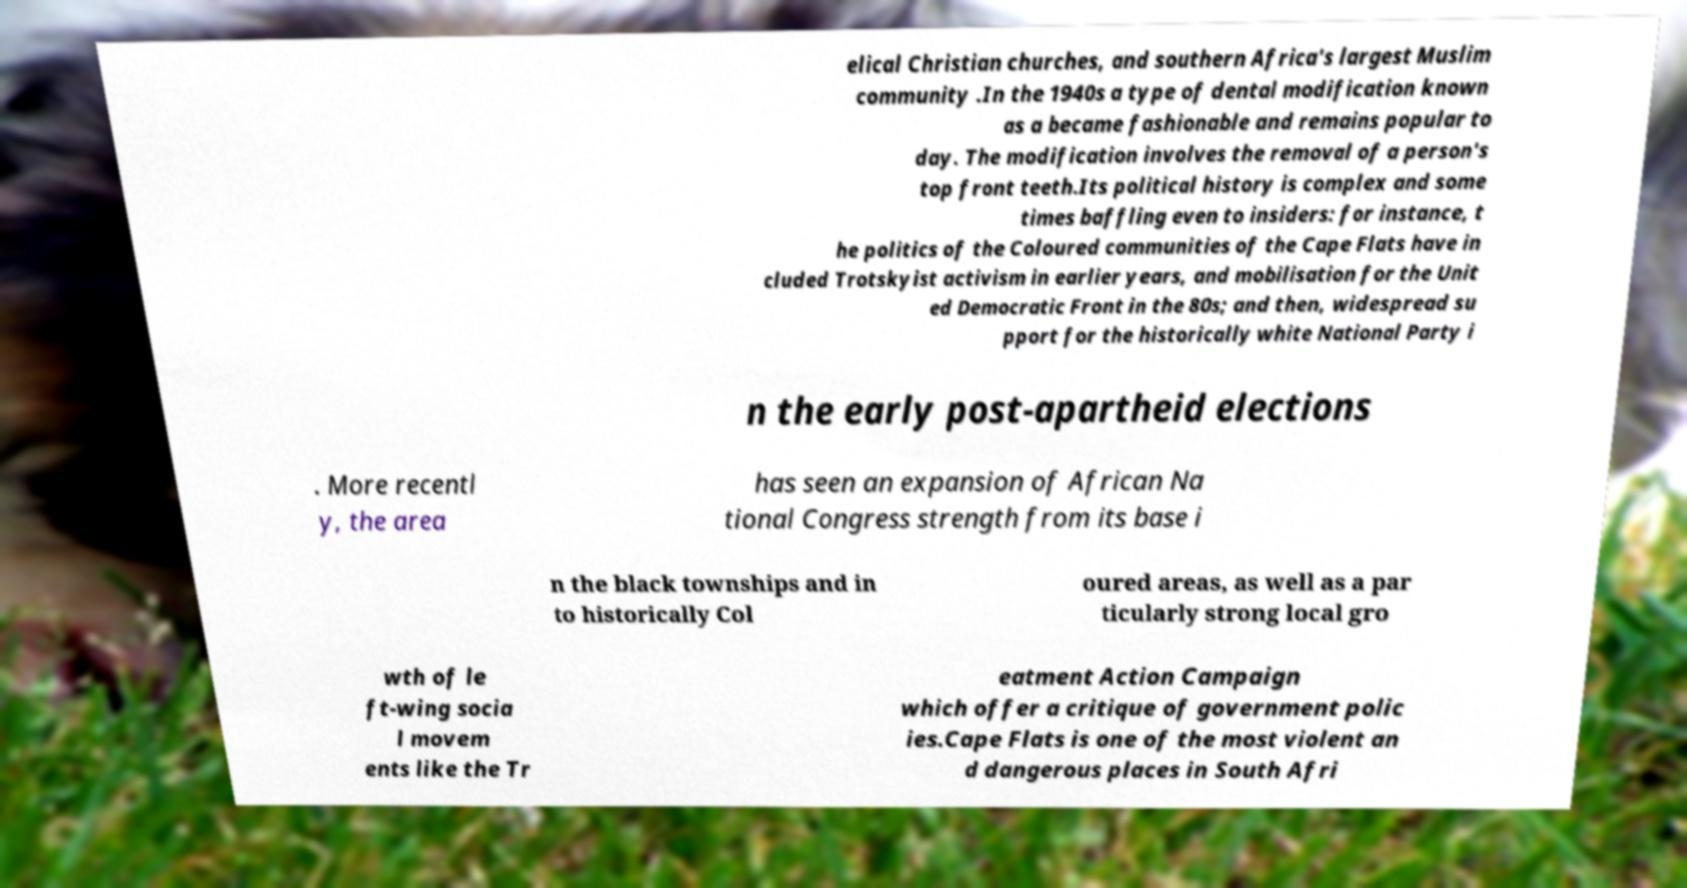What messages or text are displayed in this image? I need them in a readable, typed format. elical Christian churches, and southern Africa's largest Muslim community .In the 1940s a type of dental modification known as a became fashionable and remains popular to day. The modification involves the removal of a person's top front teeth.Its political history is complex and some times baffling even to insiders: for instance, t he politics of the Coloured communities of the Cape Flats have in cluded Trotskyist activism in earlier years, and mobilisation for the Unit ed Democratic Front in the 80s; and then, widespread su pport for the historically white National Party i n the early post-apartheid elections . More recentl y, the area has seen an expansion of African Na tional Congress strength from its base i n the black townships and in to historically Col oured areas, as well as a par ticularly strong local gro wth of le ft-wing socia l movem ents like the Tr eatment Action Campaign which offer a critique of government polic ies.Cape Flats is one of the most violent an d dangerous places in South Afri 